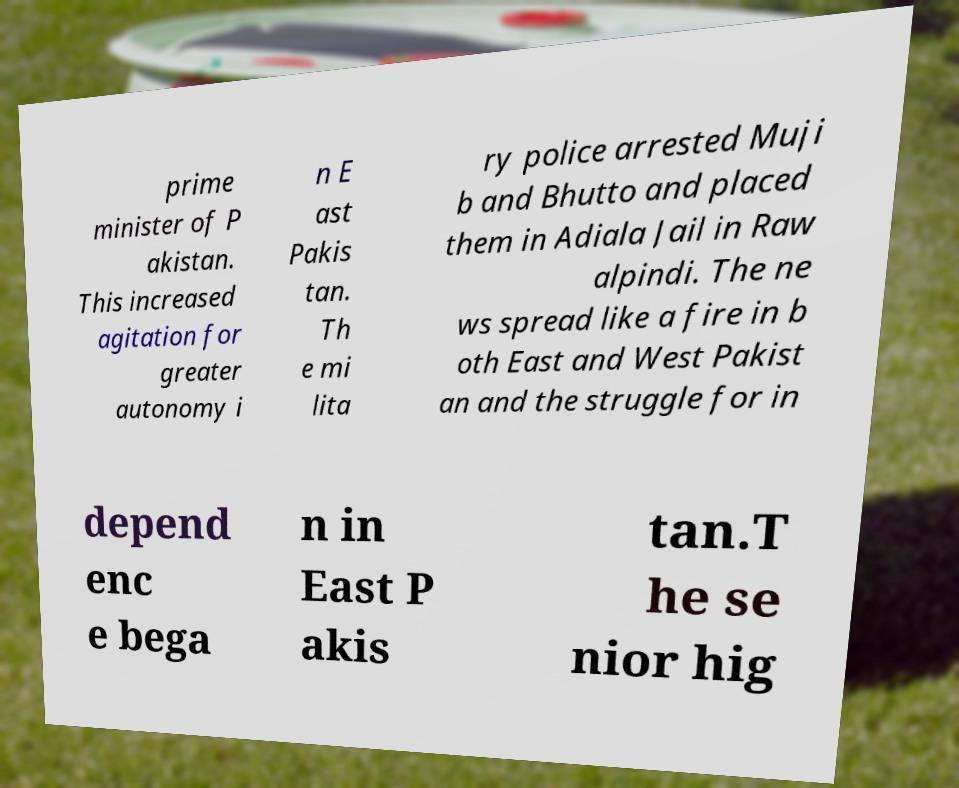Can you accurately transcribe the text from the provided image for me? prime minister of P akistan. This increased agitation for greater autonomy i n E ast Pakis tan. Th e mi lita ry police arrested Muji b and Bhutto and placed them in Adiala Jail in Raw alpindi. The ne ws spread like a fire in b oth East and West Pakist an and the struggle for in depend enc e bega n in East P akis tan.T he se nior hig 